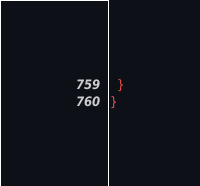<code> <loc_0><loc_0><loc_500><loc_500><_CSS_>  }
}
</code> 